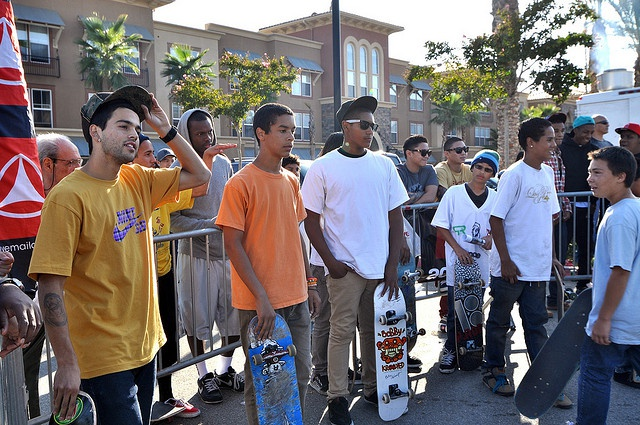Describe the objects in this image and their specific colors. I can see people in brown, olive, black, tan, and gray tones, people in brown, lavender, gray, and black tones, people in brown, salmon, gray, and black tones, people in brown, black, lightblue, lavender, and gray tones, and people in brown, black, darkgray, navy, and gray tones in this image. 